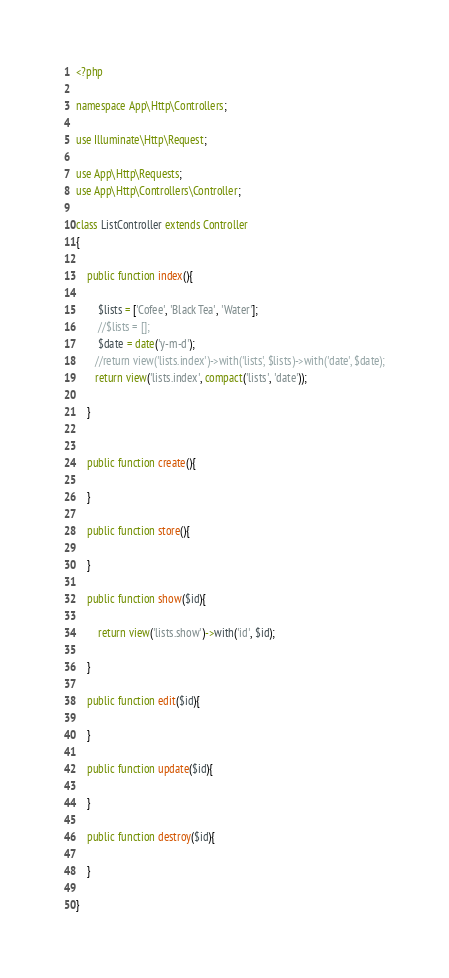<code> <loc_0><loc_0><loc_500><loc_500><_PHP_><?php

namespace App\Http\Controllers;

use Illuminate\Http\Request;

use App\Http\Requests;
use App\Http\Controllers\Controller;

class ListController extends Controller
{

    public function index(){

        $lists = ['Cofee', 'Black Tea', 'Water'];
        //$lists = [];
        $date = date('y-m-d');
       //return view('lists.index')->with('lists', $lists)->with('date', $date);
       return view('lists.index', compact('lists', 'date'));

    }


    public function create(){

    }

    public function store(){

    }

    public function show($id){

        return view('lists.show')->with('id', $id);

    }

    public function edit($id){

    }

    public function update($id){

    }

    public function destroy($id){

    }

}
</code> 